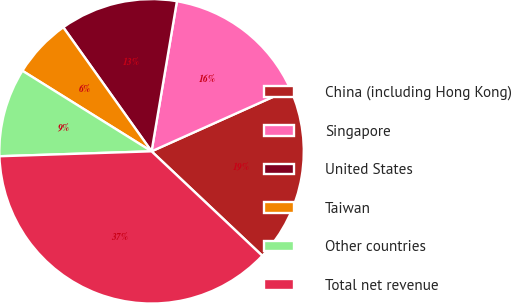<chart> <loc_0><loc_0><loc_500><loc_500><pie_chart><fcel>China (including Hong Kong)<fcel>Singapore<fcel>United States<fcel>Taiwan<fcel>Other countries<fcel>Total net revenue<nl><fcel>18.74%<fcel>15.63%<fcel>12.51%<fcel>6.28%<fcel>9.39%<fcel>37.45%<nl></chart> 